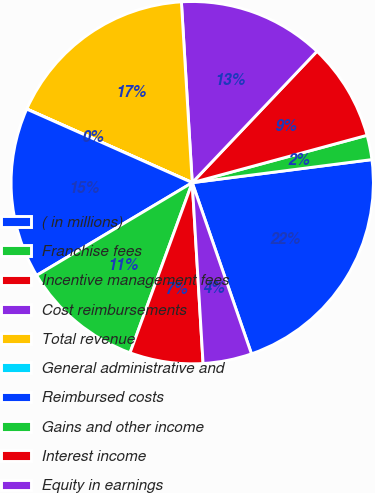Convert chart. <chart><loc_0><loc_0><loc_500><loc_500><pie_chart><fcel>( in millions)<fcel>Franchise fees<fcel>Incentive management fees<fcel>Cost reimbursements<fcel>Total revenue<fcel>General administrative and<fcel>Reimbursed costs<fcel>Gains and other income<fcel>Interest income<fcel>Equity in earnings<nl><fcel>21.73%<fcel>2.18%<fcel>8.7%<fcel>13.04%<fcel>17.38%<fcel>0.01%<fcel>15.21%<fcel>10.87%<fcel>6.53%<fcel>4.35%<nl></chart> 